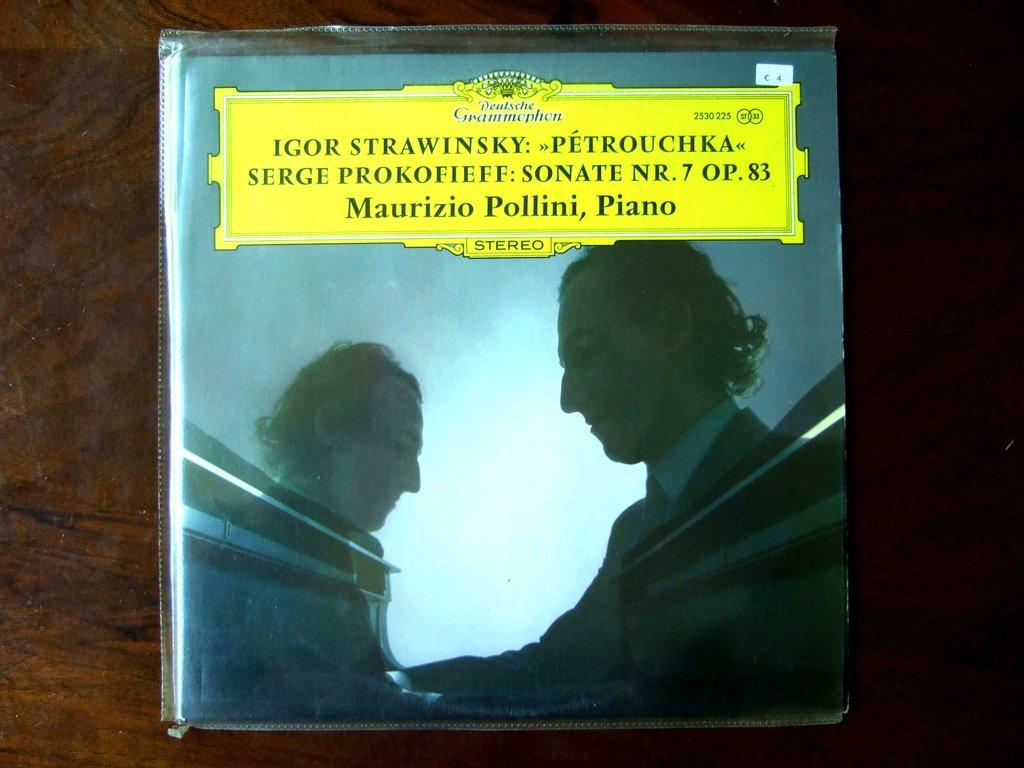What is the main subject in the center of the image? There is a book in the center of the image. Where is the book located? The book is on a table. What can be seen on the book cover? There are humans depicted on the book cover. What else can be observed about the book? There is text visible on the book. What type of hole can be seen in the book in the image? There is no hole present in the book or the image. What kind of furniture is depicted in the image? The image only shows a book on a table, and there is no other furniture depicted. 